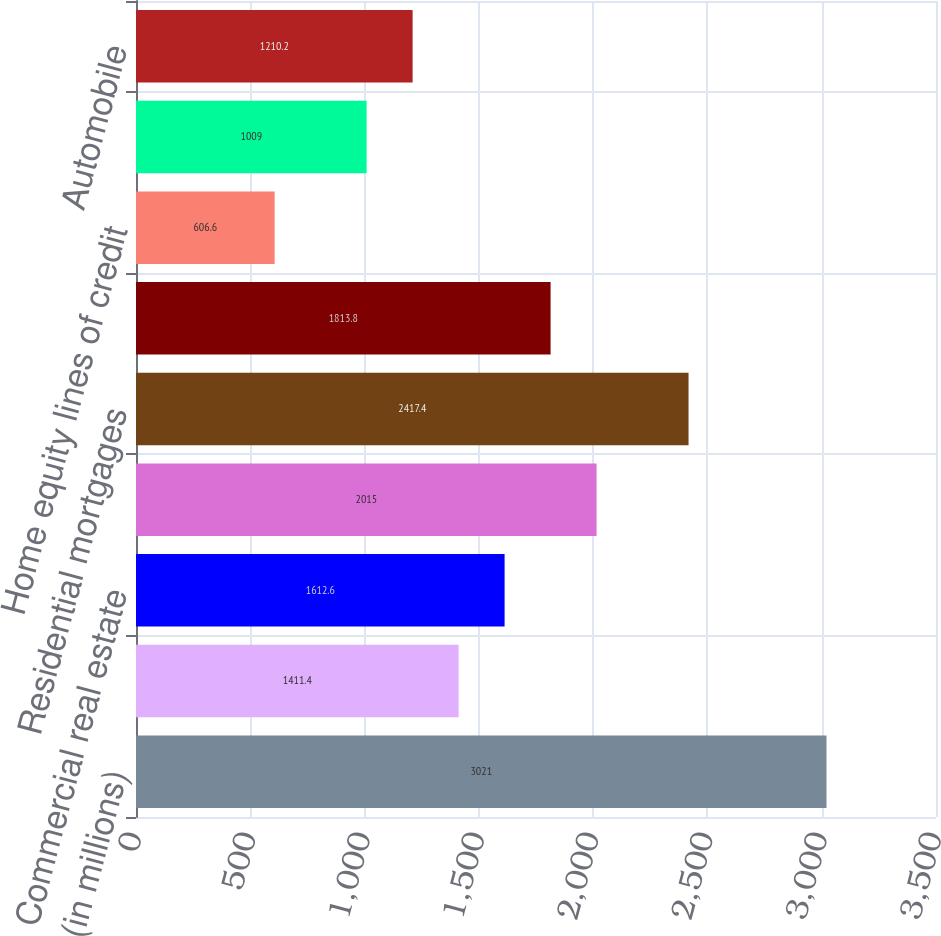<chart> <loc_0><loc_0><loc_500><loc_500><bar_chart><fcel>(in millions)<fcel>Commercial<fcel>Commercial real estate<fcel>Total commercial<fcel>Residential mortgages<fcel>Home equity loans<fcel>Home equity lines of credit<fcel>Home equity loans serviced by<fcel>Automobile<nl><fcel>3021<fcel>1411.4<fcel>1612.6<fcel>2015<fcel>2417.4<fcel>1813.8<fcel>606.6<fcel>1009<fcel>1210.2<nl></chart> 